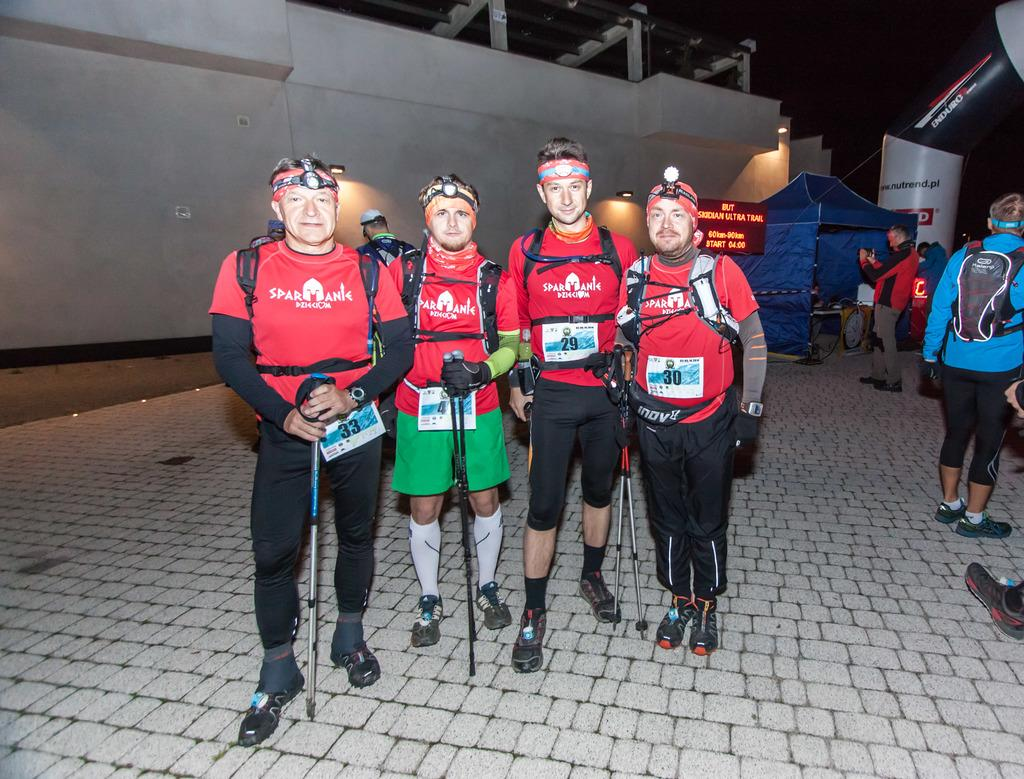What are the people in the image doing? The people in the image are standing on the floor. What can be seen on the floor in the image? There is a board on the floor in the image. What type of temporary shelter is visible in the image? There is a tent in the image. What is the large sign in the image called? There is a hoarding in the image. What else is present in the image besides the people and the board? There are objects in the image. What is visible in the background of the image? There is a wall in the background of the image. What position does the army hold in the image? There is no army present in the image. What causes shame in the image? There is no indication of shame in the image. 